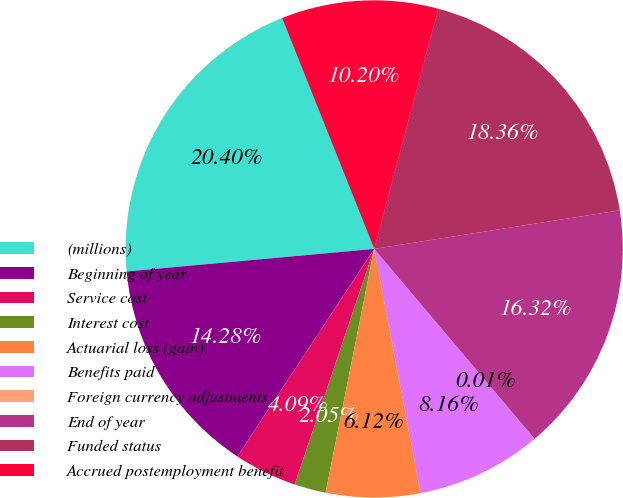Convert chart. <chart><loc_0><loc_0><loc_500><loc_500><pie_chart><fcel>(millions)<fcel>Beginning of year<fcel>Service cost<fcel>Interest cost<fcel>Actuarial loss (gain)<fcel>Benefits paid<fcel>Foreign currency adjustments<fcel>End of year<fcel>Funded status<fcel>Accrued postemployment benefit<nl><fcel>20.4%<fcel>14.28%<fcel>4.09%<fcel>2.05%<fcel>6.12%<fcel>8.16%<fcel>0.01%<fcel>16.32%<fcel>18.36%<fcel>10.2%<nl></chart> 